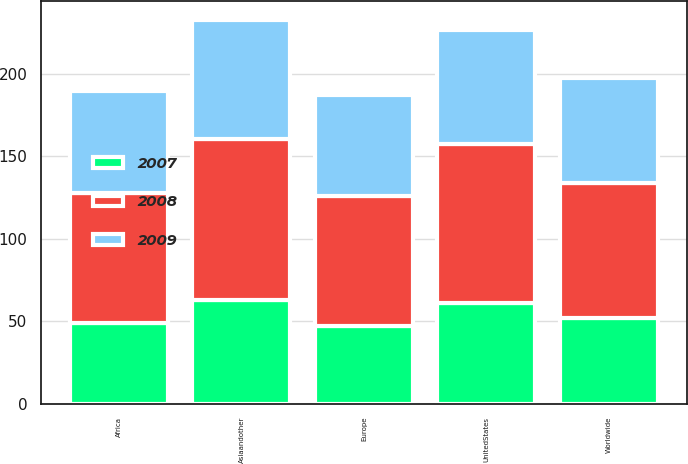Convert chart to OTSL. <chart><loc_0><loc_0><loc_500><loc_500><stacked_bar_chart><ecel><fcel>UnitedStates<fcel>Europe<fcel>Africa<fcel>Asiaandother<fcel>Worldwide<nl><fcel>2007<fcel>60.67<fcel>47.02<fcel>48.91<fcel>63.01<fcel>51.62<nl><fcel>2008<fcel>96.82<fcel>78.75<fcel>78.72<fcel>97.07<fcel>82.04<nl><fcel>2009<fcel>69.23<fcel>60.99<fcel>62.04<fcel>72.17<fcel>63.44<nl></chart> 